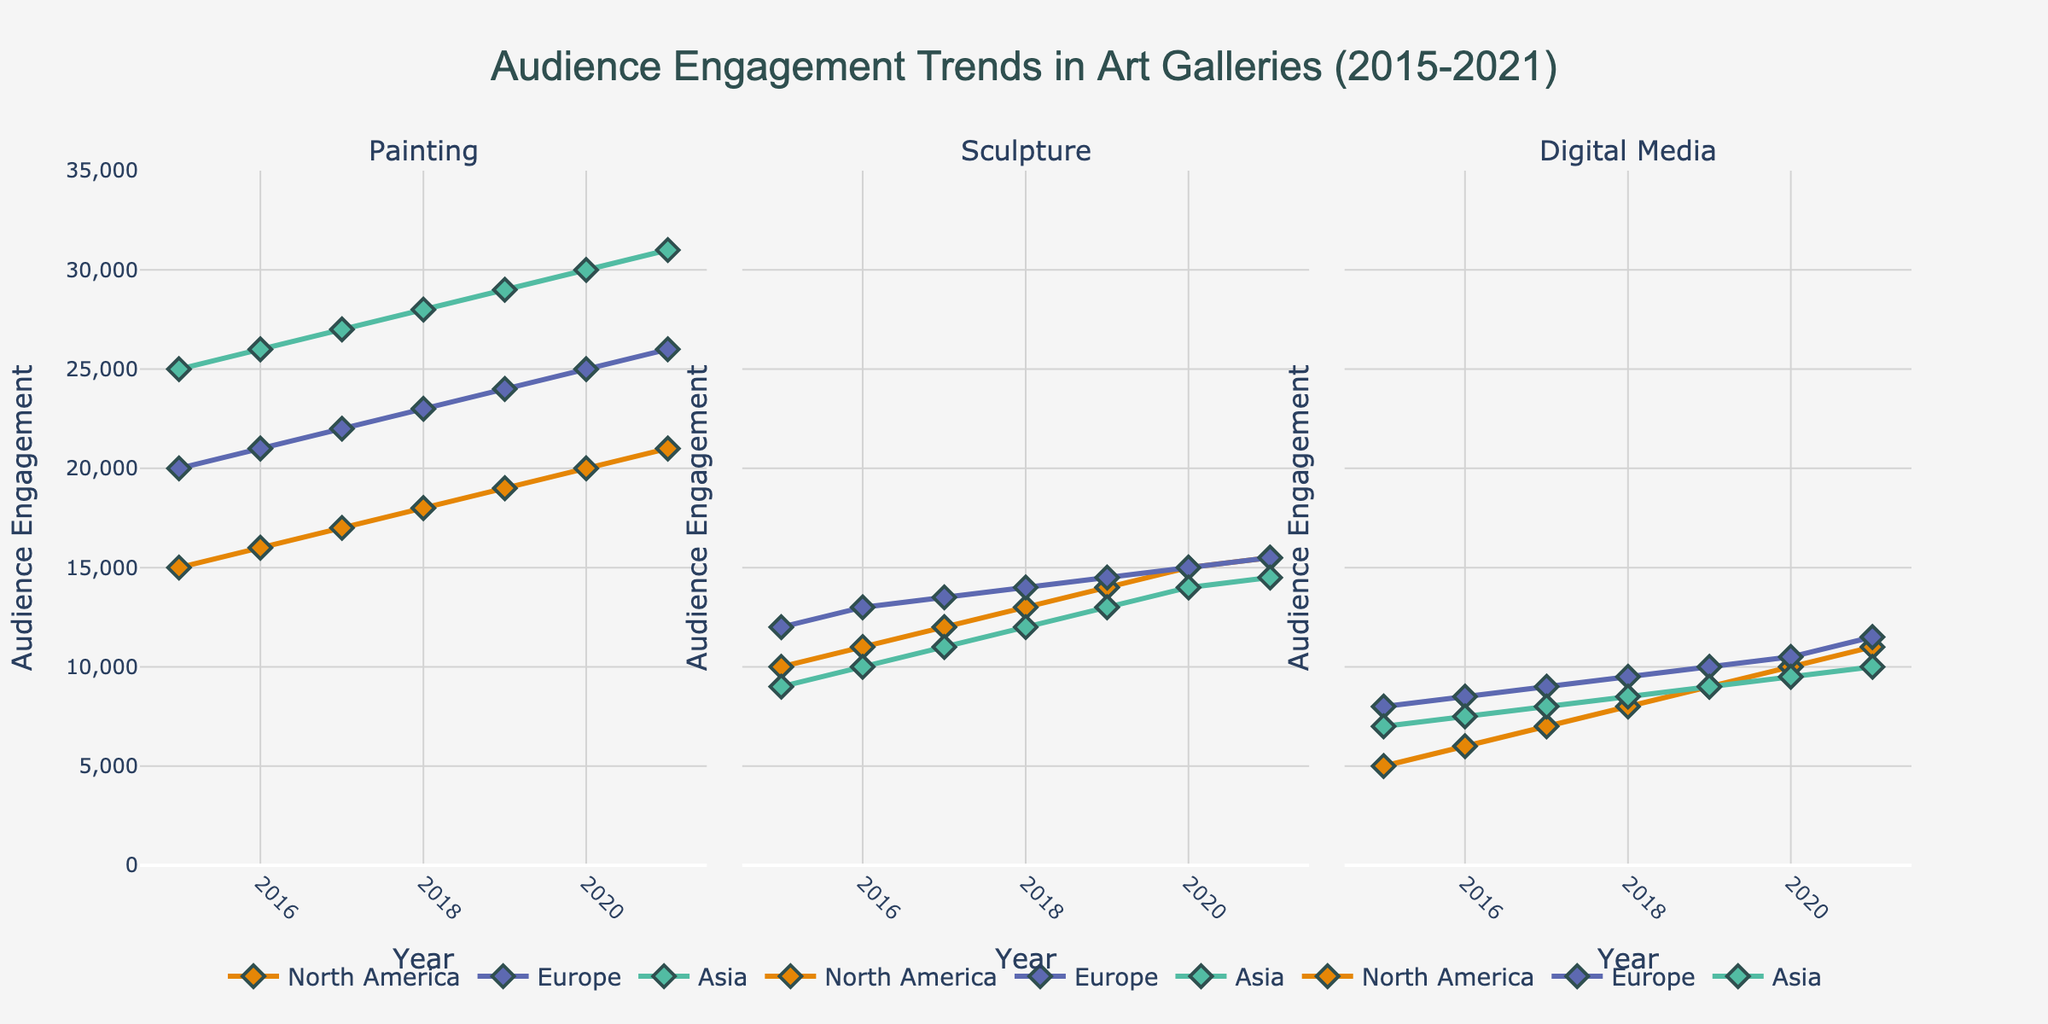What is the range of audience engagement for North America's digital media from 2015 to 2021? Look at the "Digital Media" subplot and examine the line representing North America. Identify the minimum and maximum values on the y-axis for North America from 2015 to 2021. The line for North America in digital media starts at 5,000 in 2015 and ends at 11,000 in 2021.
Answer: 5,000 - 11,000 What is the average audience engagement for painting in Europe over the given period? Refer to the "Painting" subplot and examine the line representing Europe. The engagement values from 2015 to 2021 are 20,000, 21,000, 22,000, 23,000, 24,000, 25,000, and 26,000. Sum these values and divide by the number of years: (20,000 + 21,000 + 22,000 + 23,000 + 24,000 + 25,000 + 26,000) / 7 = 161,000 / 7.
Answer: 23,000 Which region shows the highest audience engagement for sculpture in 2021? Look at the "Sculpture" subplot and compare the values for North America, Europe, and Asia in 2021. North America's value is 15,500, Europe's is 15,500, and Asia's is 14,500. Both North America and Europe have the same highest audience engagement.
Answer: North America and Europe What is the percentage increase in audience engagement for paintings in Asia from 2015 to 2021? In the "Painting" subplot, identify the values for Asia in 2015 (25,000) and 2021 (31,000). Calculate the percentage increase: ((31,000 - 25,000) / 25,000) * 100. This results in a percentage increase calculation as (6,000 / 25,000) * 100.
Answer: 24% Between 2018 and 2020, which region saw the most significant increase in audience engagement for digital media? In the "Digital Media" subplot, identify the engagement values for North America, Europe, and Asia in 2018 and 2020. North America's values increase from 8,000 to 10,000 (2,000 increase), Europe's from 9,500 to 10,500 (1,000 increase), and Asia's from 8,500 to 9,500 (1,000 increase). North America shows the highest increase.
Answer: North America How has the trend for audience engagement in sculptures changed in Asia from 2015 to 2021? Examine the "Sculpture" subplot, focusing on the line for Asia. Starting at 9,000 in 2015, engagement gradually increases to 10,000 in 2016, 11,000 in 2017, continues to rise to 12,000 in 2018, 13,000 in 2019, peaks at 14,000 in 2020, and slightly increases to 14,500 in 2021.
Answer: Increasing trend Which year shows the highest total audience engagement across all regions for painting? In the "Painting" subplot, sum the audience engagements for each year across all regions.  For 2021, the total is 21,000 (NA) + 26,000 (EU) + 31,000 (AS) = 78,000, which is the highest total.
Answer: 2021 What is the difference in audience engagement for digital media between Europe and Asia in 2021? In the "Digital Media" subplot, examine the audience engagement for Europe (11,500) and Asia (10,000) in 2021. Calculate the difference: 11,500 - 10,000.
Answer: 1,500 How did the audience engagement for sculptures in North America change from 2018 to 2020? In the "Sculpture" subplot, for North America, note the values in 2018 (13,000) and 2020 (15,000). Highlight the increase from 13,000 to 15,000.
Answer: Increased Which art form shows the most consistent growth in audience engagement in Asia from 2015 to 2021? Examine the trends in the "Painting," "Sculpture," and "Digital Media" subplots for Asia. Painting shows steady increases, whereas Sculpture and Digital Media show smaller fluctuations.
Answer: Painting 